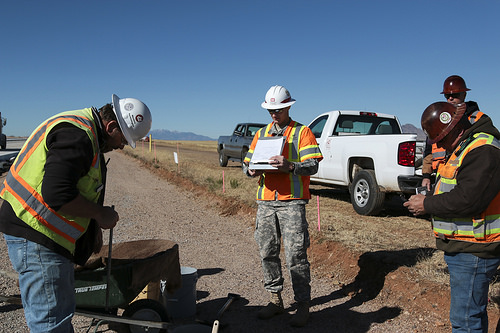<image>
Can you confirm if the car is behind the man? Yes. From this viewpoint, the car is positioned behind the man, with the man partially or fully occluding the car. Is the sticker above the jeans? Yes. The sticker is positioned above the jeans in the vertical space, higher up in the scene. 